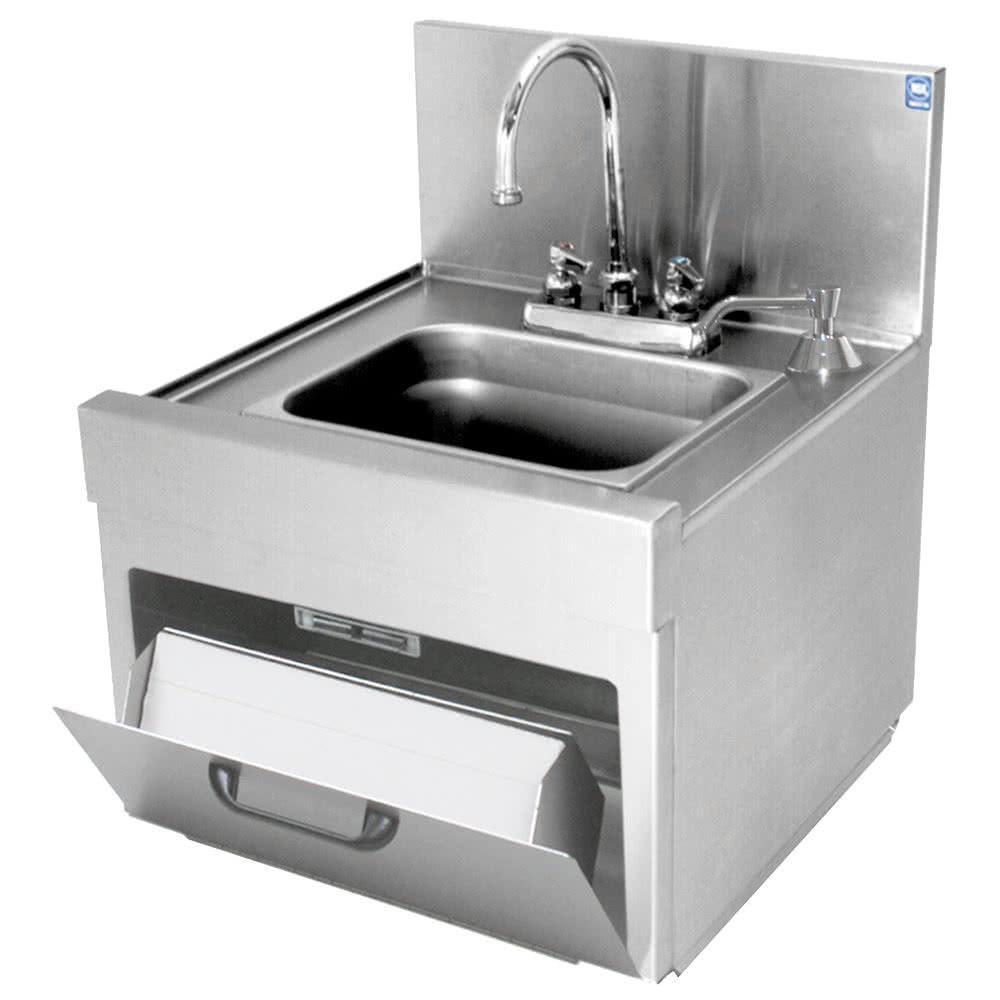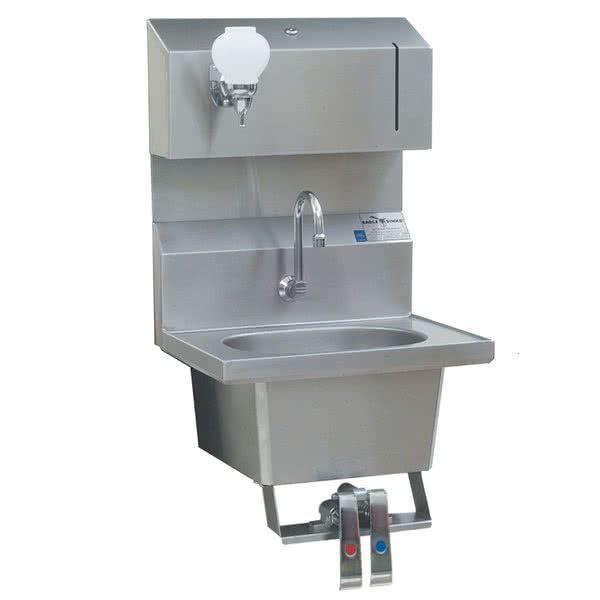The first image is the image on the left, the second image is the image on the right. For the images displayed, is the sentence "There are two sinks, and none of them have legs." factually correct? Answer yes or no. Yes. The first image is the image on the left, the second image is the image on the right. Evaluate the accuracy of this statement regarding the images: "The left and right image contains the same number of  hanging sinks.". Is it true? Answer yes or no. Yes. 